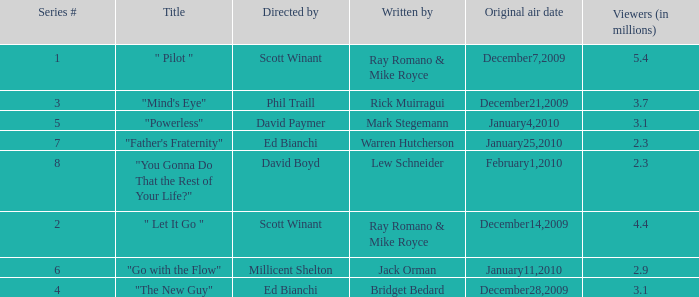When did the episode  "you gonna do that the rest of your life?" air? February1,2010. 